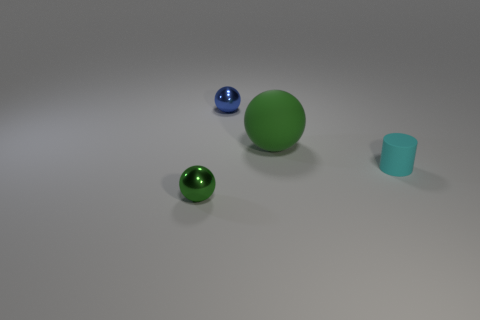Are there any other things that have the same size as the green matte ball?
Offer a terse response. No. There is a sphere that is in front of the tiny blue thing and behind the tiny cylinder; how big is it?
Provide a succinct answer. Large. Are there fewer metal balls that are on the right side of the green shiny sphere than objects in front of the big green matte thing?
Offer a terse response. Yes. Are the green sphere that is behind the cyan matte cylinder and the tiny thing that is in front of the small cylinder made of the same material?
Provide a succinct answer. No. There is another tiny ball that is the same color as the rubber ball; what is its material?
Provide a short and direct response. Metal. What is the shape of the object that is both on the left side of the cylinder and in front of the large green object?
Make the answer very short. Sphere. There is a green thing on the right side of the metallic ball that is in front of the small cyan object; what is its material?
Your response must be concise. Rubber. Is the number of matte cylinders greater than the number of tiny blue blocks?
Your answer should be very brief. Yes. Is the large thing the same color as the cylinder?
Provide a short and direct response. No. What is the material of the green sphere that is the same size as the cyan cylinder?
Your answer should be compact. Metal. 